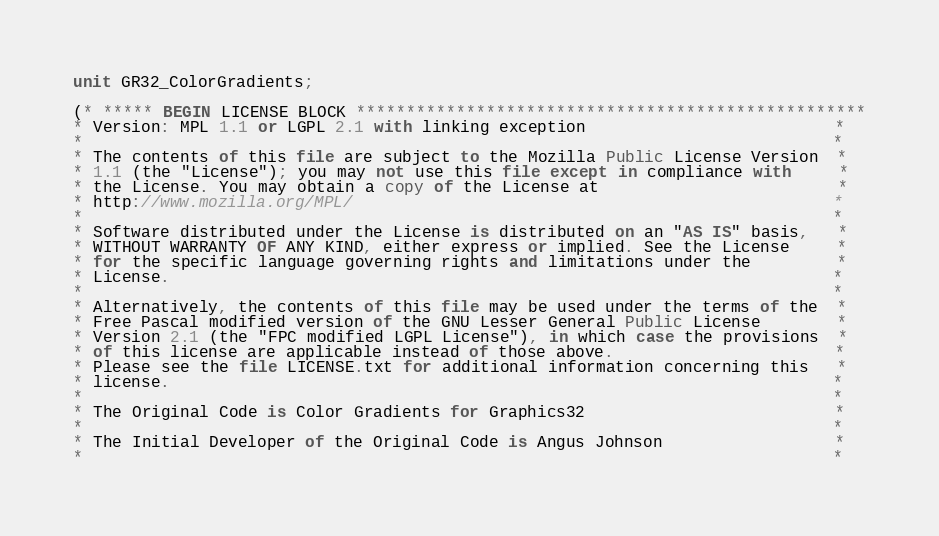Convert code to text. <code><loc_0><loc_0><loc_500><loc_500><_Pascal_>unit GR32_ColorGradients;

(* ***** BEGIN LICENSE BLOCK ***************************************************
* Version: MPL 1.1 or LGPL 2.1 with linking exception                          *
*                                                                              *
* The contents of this file are subject to the Mozilla Public License Version  *
* 1.1 (the "License"); you may not use this file except in compliance with     *
* the License. You may obtain a copy of the License at                         *
* http://www.mozilla.org/MPL/                                                  *
*                                                                              *
* Software distributed under the License is distributed on an "AS IS" basis,   *
* WITHOUT WARRANTY OF ANY KIND, either express or implied. See the License     *
* for the specific language governing rights and limitations under the         *
* License.                                                                     *
*                                                                              *
* Alternatively, the contents of this file may be used under the terms of the  *
* Free Pascal modified version of the GNU Lesser General Public License        *
* Version 2.1 (the "FPC modified LGPL License"), in which case the provisions  *
* of this license are applicable instead of those above.                       *
* Please see the file LICENSE.txt for additional information concerning this   *
* license.                                                                     *
*                                                                              *
* The Original Code is Color Gradients for Graphics32                          *
*                                                                              *
* The Initial Developer of the Original Code is Angus Johnson                  *
*                                                                              *</code> 